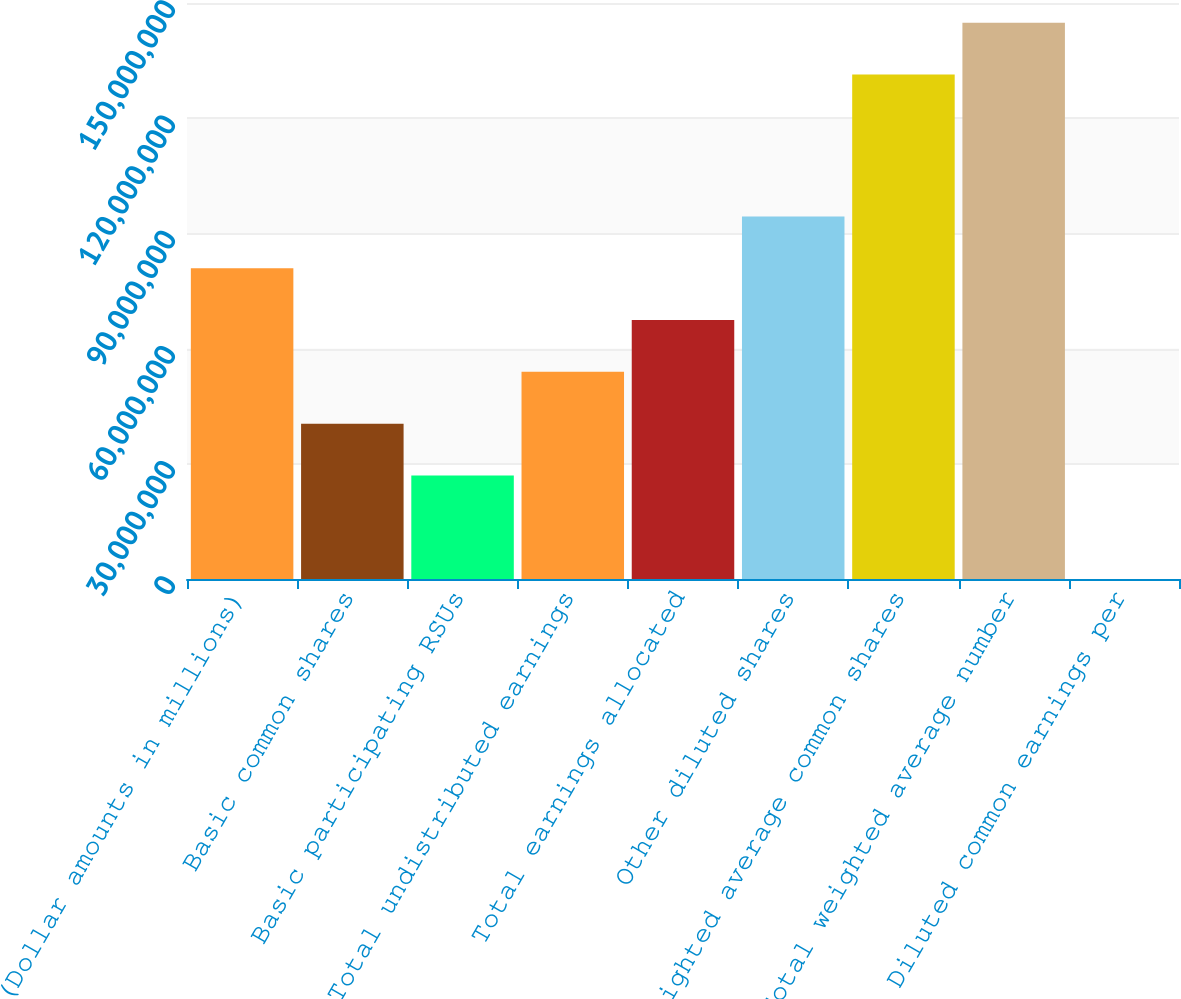Convert chart. <chart><loc_0><loc_0><loc_500><loc_500><bar_chart><fcel>(Dollar amounts in millions)<fcel>Basic common shares<fcel>Basic participating RSUs<fcel>Total undistributed earnings<fcel>Total earnings allocated<fcel>Other diluted shares<fcel>Weighted average common shares<fcel>Total weighted average number<fcel>Diluted common earnings per<nl><fcel>8.091e+07<fcel>4.0455e+07<fcel>2.697e+07<fcel>5.394e+07<fcel>6.7425e+07<fcel>9.4395e+07<fcel>1.31378e+08<fcel>1.44863e+08<fcel>7.37<nl></chart> 